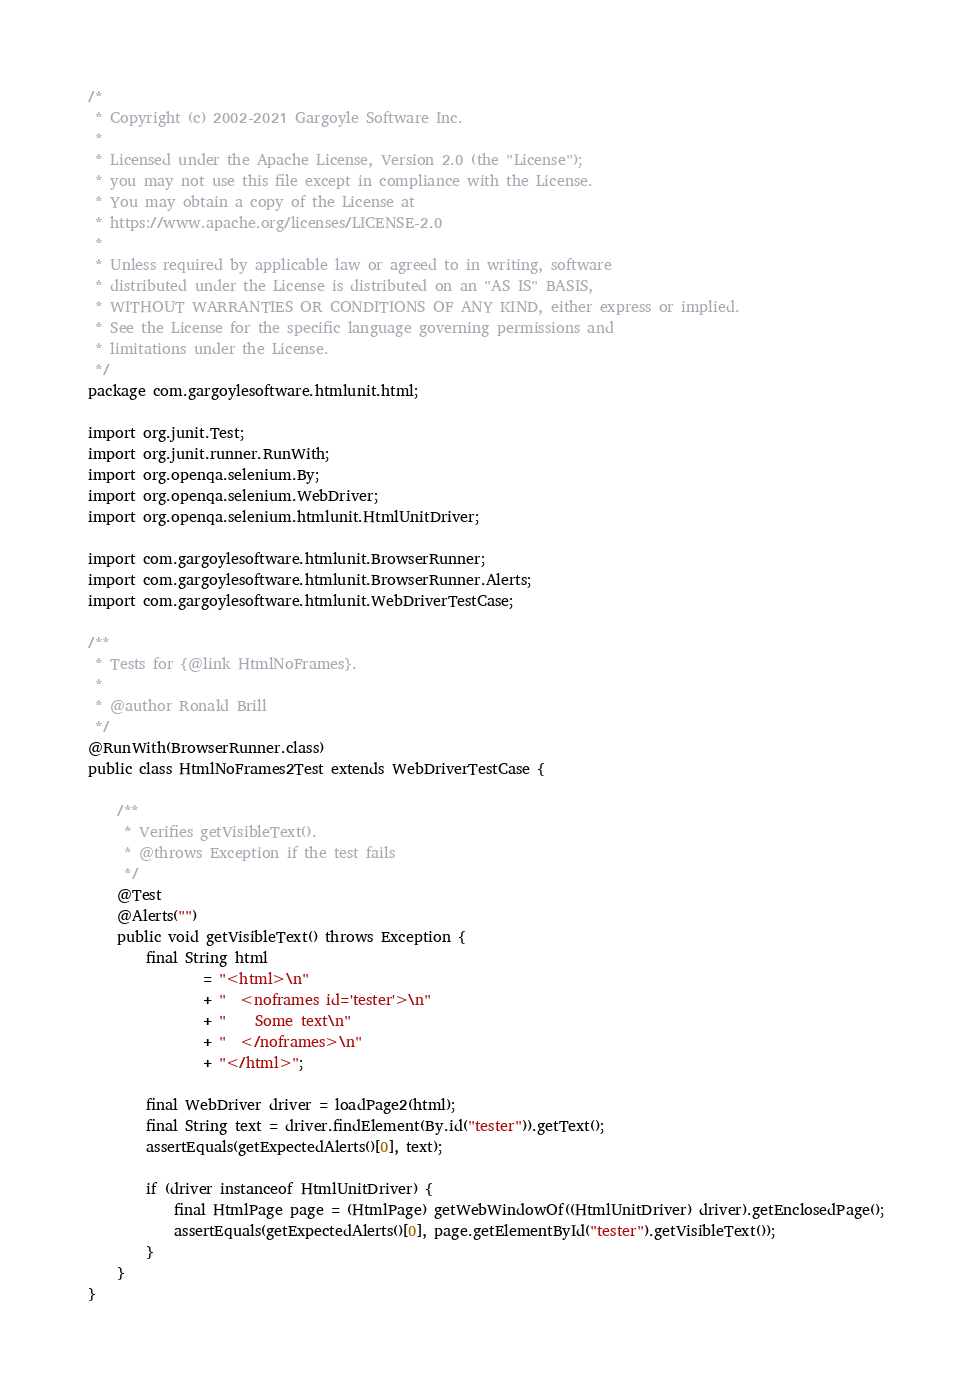Convert code to text. <code><loc_0><loc_0><loc_500><loc_500><_Java_>/*
 * Copyright (c) 2002-2021 Gargoyle Software Inc.
 *
 * Licensed under the Apache License, Version 2.0 (the "License");
 * you may not use this file except in compliance with the License.
 * You may obtain a copy of the License at
 * https://www.apache.org/licenses/LICENSE-2.0
 *
 * Unless required by applicable law or agreed to in writing, software
 * distributed under the License is distributed on an "AS IS" BASIS,
 * WITHOUT WARRANTIES OR CONDITIONS OF ANY KIND, either express or implied.
 * See the License for the specific language governing permissions and
 * limitations under the License.
 */
package com.gargoylesoftware.htmlunit.html;

import org.junit.Test;
import org.junit.runner.RunWith;
import org.openqa.selenium.By;
import org.openqa.selenium.WebDriver;
import org.openqa.selenium.htmlunit.HtmlUnitDriver;

import com.gargoylesoftware.htmlunit.BrowserRunner;
import com.gargoylesoftware.htmlunit.BrowserRunner.Alerts;
import com.gargoylesoftware.htmlunit.WebDriverTestCase;

/**
 * Tests for {@link HtmlNoFrames}.
 *
 * @author Ronald Brill
 */
@RunWith(BrowserRunner.class)
public class HtmlNoFrames2Test extends WebDriverTestCase {

    /**
     * Verifies getVisibleText().
     * @throws Exception if the test fails
     */
    @Test
    @Alerts("")
    public void getVisibleText() throws Exception {
        final String html
                = "<html>\n"
                + "  <noframes id='tester'>\n"
                + "    Some text\n"
                + "  </noframes>\n"
                + "</html>";

        final WebDriver driver = loadPage2(html);
        final String text = driver.findElement(By.id("tester")).getText();
        assertEquals(getExpectedAlerts()[0], text);

        if (driver instanceof HtmlUnitDriver) {
            final HtmlPage page = (HtmlPage) getWebWindowOf((HtmlUnitDriver) driver).getEnclosedPage();
            assertEquals(getExpectedAlerts()[0], page.getElementById("tester").getVisibleText());
        }
    }
}
</code> 